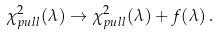<formula> <loc_0><loc_0><loc_500><loc_500>\chi ^ { 2 } _ { p u l l } ( \lambda ) \rightarrow \chi ^ { 2 } _ { p u l l } ( \lambda ) + f ( \lambda ) \, .</formula> 